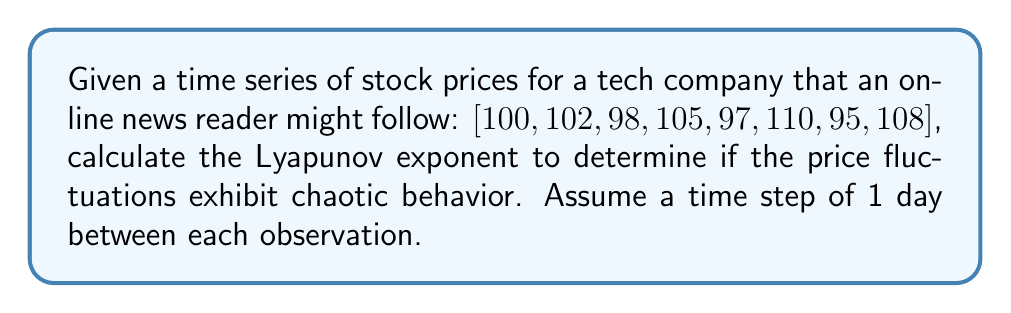Teach me how to tackle this problem. To calculate the Lyapunov exponent for this time series, we'll follow these steps:

1) First, we need to calculate the differences between consecutive points:
   $[2, -4, 7, -8, 13, -15, 13]$

2) Next, we calculate the natural logarithm of the absolute values of these differences:
   $[\ln(2), \ln(4), \ln(7), \ln(8), \ln(13), \ln(15), \ln(13)]$

3) We sum these logarithms:
   $\sum = \ln(2) + \ln(4) + \ln(7) + \ln(8) + \ln(13) + \ln(15) + \ln(13)$

4) We divide by the number of terms (7) and the time step (1 day):
   $$\lambda = \frac{1}{7 \cdot 1} [\ln(2) + \ln(4) + \ln(7) + \ln(8) + \ln(13) + \ln(15) + \ln(13)]$$

5) Simplifying:
   $$\lambda = \frac{1}{7} [\ln(2) + \ln(4) + \ln(7) + \ln(8) + \ln(13) + \ln(15) + \ln(13)]$$

6) Calculating:
   $$\lambda \approx 0.3114$$

A positive Lyapunov exponent indicates chaotic behavior in the time series. The magnitude suggests the degree of chaos, with larger values indicating more chaotic systems.
Answer: $\lambda \approx 0.3114$ 